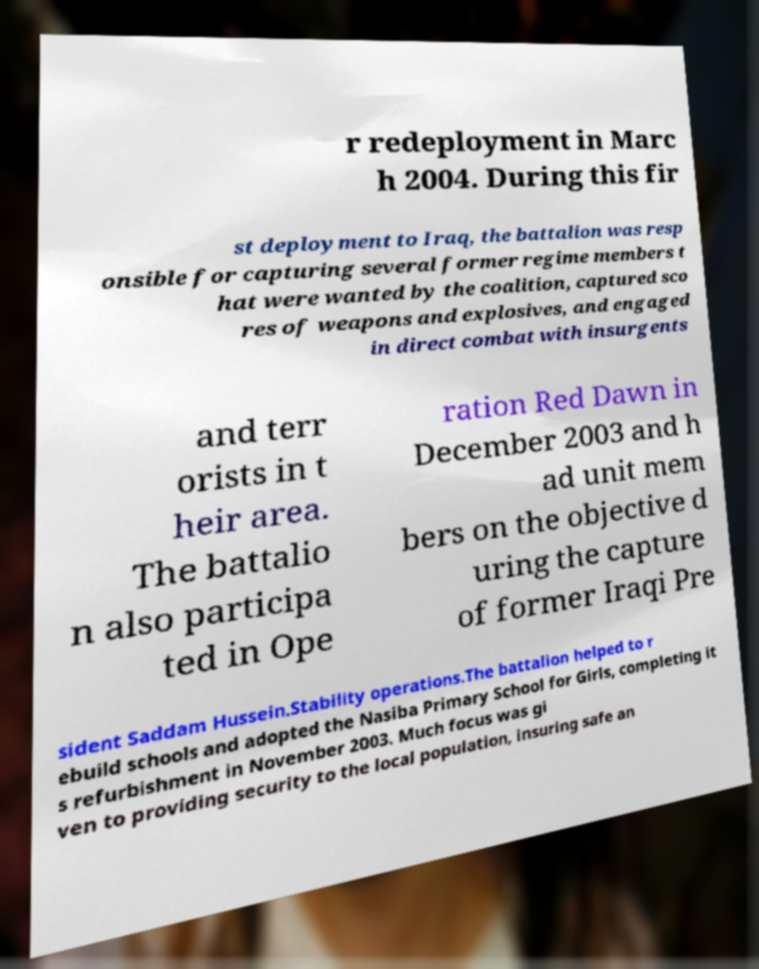Can you accurately transcribe the text from the provided image for me? r redeployment in Marc h 2004. During this fir st deployment to Iraq, the battalion was resp onsible for capturing several former regime members t hat were wanted by the coalition, captured sco res of weapons and explosives, and engaged in direct combat with insurgents and terr orists in t heir area. The battalio n also participa ted in Ope ration Red Dawn in December 2003 and h ad unit mem bers on the objective d uring the capture of former Iraqi Pre sident Saddam Hussein.Stability operations.The battalion helped to r ebuild schools and adopted the Nasiba Primary School for Girls, completing it s refurbishment in November 2003. Much focus was gi ven to providing security to the local population, insuring safe an 